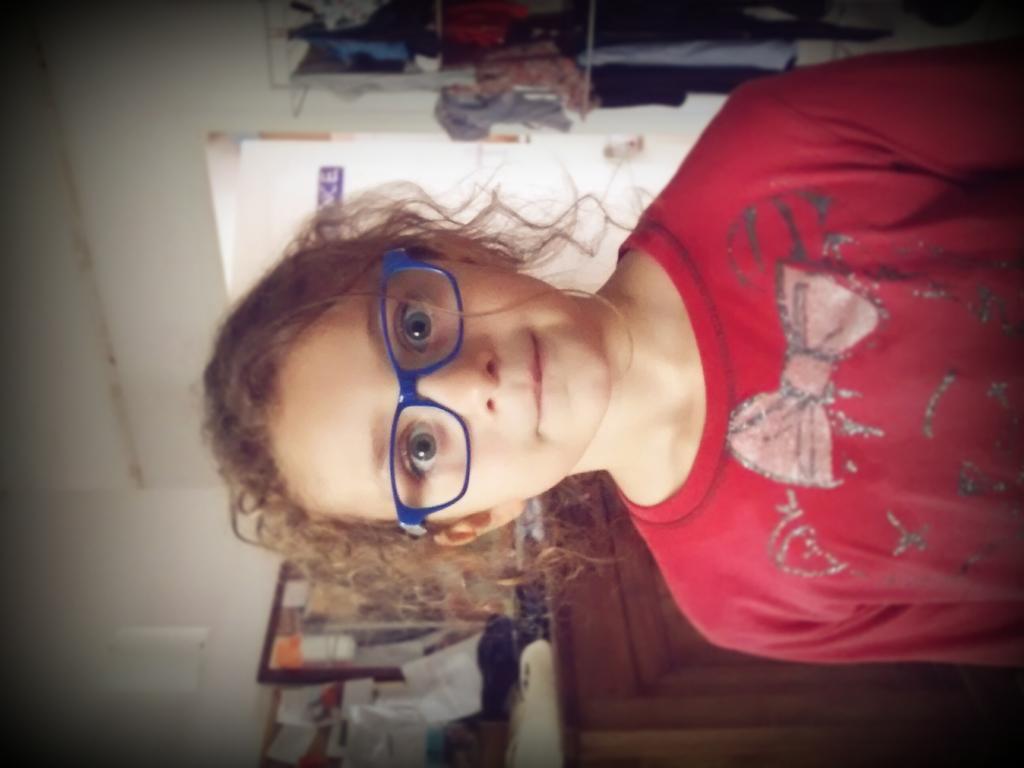How would you summarize this image in a sentence or two? In this picture there is a girl in red t-shirt and wearing blue spectacles. In the background there are papers, notice board, desk and other objects and there are door, closet, cloth. On the left it is wall painted white. 